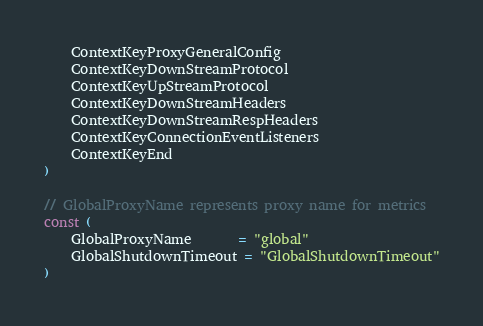<code> <loc_0><loc_0><loc_500><loc_500><_Go_>	ContextKeyProxyGeneralConfig
	ContextKeyDownStreamProtocol
	ContextKeyUpStreamProtocol
	ContextKeyDownStreamHeaders
	ContextKeyDownStreamRespHeaders
	ContextKeyConnectionEventListeners
	ContextKeyEnd
)

// GlobalProxyName represents proxy name for metrics
const (
	GlobalProxyName       = "global"
	GlobalShutdownTimeout = "GlobalShutdownTimeout"
)
</code> 